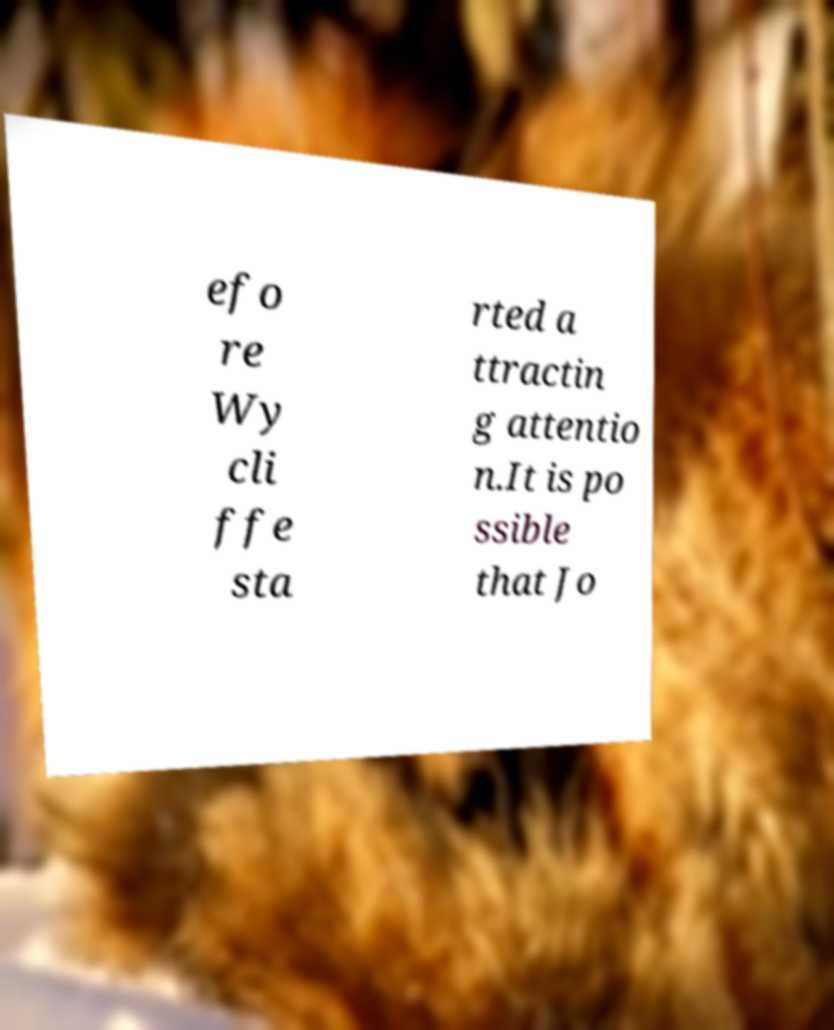Can you read and provide the text displayed in the image?This photo seems to have some interesting text. Can you extract and type it out for me? efo re Wy cli ffe sta rted a ttractin g attentio n.It is po ssible that Jo 